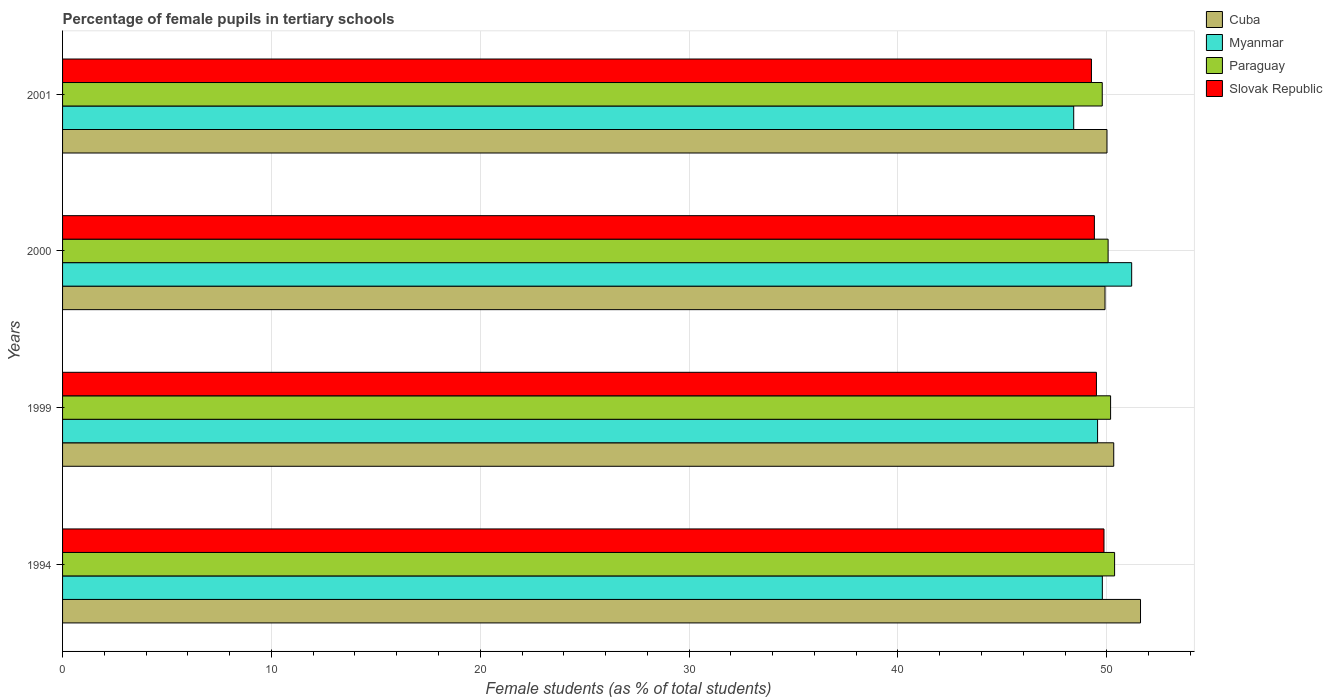Are the number of bars on each tick of the Y-axis equal?
Offer a terse response. Yes. How many bars are there on the 2nd tick from the top?
Give a very brief answer. 4. How many bars are there on the 2nd tick from the bottom?
Provide a short and direct response. 4. What is the percentage of female pupils in tertiary schools in Myanmar in 1994?
Give a very brief answer. 49.79. Across all years, what is the maximum percentage of female pupils in tertiary schools in Cuba?
Your answer should be very brief. 51.62. Across all years, what is the minimum percentage of female pupils in tertiary schools in Myanmar?
Offer a terse response. 48.42. In which year was the percentage of female pupils in tertiary schools in Cuba maximum?
Your answer should be very brief. 1994. In which year was the percentage of female pupils in tertiary schools in Paraguay minimum?
Your response must be concise. 2001. What is the total percentage of female pupils in tertiary schools in Cuba in the graph?
Keep it short and to the point. 201.88. What is the difference between the percentage of female pupils in tertiary schools in Paraguay in 1999 and that in 2001?
Make the answer very short. 0.4. What is the difference between the percentage of female pupils in tertiary schools in Paraguay in 2000 and the percentage of female pupils in tertiary schools in Slovak Republic in 2001?
Provide a succinct answer. 0.8. What is the average percentage of female pupils in tertiary schools in Cuba per year?
Provide a short and direct response. 50.47. In the year 2001, what is the difference between the percentage of female pupils in tertiary schools in Cuba and percentage of female pupils in tertiary schools in Paraguay?
Provide a short and direct response. 0.23. In how many years, is the percentage of female pupils in tertiary schools in Slovak Republic greater than 38 %?
Your answer should be compact. 4. What is the ratio of the percentage of female pupils in tertiary schools in Paraguay in 1994 to that in 1999?
Offer a terse response. 1. Is the difference between the percentage of female pupils in tertiary schools in Cuba in 1994 and 2001 greater than the difference between the percentage of female pupils in tertiary schools in Paraguay in 1994 and 2001?
Offer a very short reply. Yes. What is the difference between the highest and the second highest percentage of female pupils in tertiary schools in Myanmar?
Keep it short and to the point. 1.4. What is the difference between the highest and the lowest percentage of female pupils in tertiary schools in Paraguay?
Provide a succinct answer. 0.59. In how many years, is the percentage of female pupils in tertiary schools in Paraguay greater than the average percentage of female pupils in tertiary schools in Paraguay taken over all years?
Keep it short and to the point. 2. Is it the case that in every year, the sum of the percentage of female pupils in tertiary schools in Myanmar and percentage of female pupils in tertiary schools in Slovak Republic is greater than the sum of percentage of female pupils in tertiary schools in Paraguay and percentage of female pupils in tertiary schools in Cuba?
Give a very brief answer. No. What does the 3rd bar from the top in 1994 represents?
Make the answer very short. Myanmar. What does the 2nd bar from the bottom in 1999 represents?
Ensure brevity in your answer.  Myanmar. How many bars are there?
Provide a short and direct response. 16. Does the graph contain any zero values?
Make the answer very short. No. What is the title of the graph?
Keep it short and to the point. Percentage of female pupils in tertiary schools. What is the label or title of the X-axis?
Ensure brevity in your answer.  Female students (as % of total students). What is the label or title of the Y-axis?
Your answer should be compact. Years. What is the Female students (as % of total students) in Cuba in 1994?
Offer a terse response. 51.62. What is the Female students (as % of total students) of Myanmar in 1994?
Provide a succinct answer. 49.79. What is the Female students (as % of total students) in Paraguay in 1994?
Your answer should be very brief. 50.37. What is the Female students (as % of total students) of Slovak Republic in 1994?
Ensure brevity in your answer.  49.87. What is the Female students (as % of total students) of Cuba in 1999?
Provide a succinct answer. 50.33. What is the Female students (as % of total students) in Myanmar in 1999?
Your answer should be very brief. 49.56. What is the Female students (as % of total students) in Paraguay in 1999?
Your answer should be very brief. 50.18. What is the Female students (as % of total students) of Slovak Republic in 1999?
Make the answer very short. 49.51. What is the Female students (as % of total students) in Cuba in 2000?
Your answer should be compact. 49.92. What is the Female students (as % of total students) in Myanmar in 2000?
Keep it short and to the point. 51.19. What is the Female students (as % of total students) in Paraguay in 2000?
Offer a very short reply. 50.06. What is the Female students (as % of total students) of Slovak Republic in 2000?
Offer a terse response. 49.41. What is the Female students (as % of total students) in Cuba in 2001?
Keep it short and to the point. 50.01. What is the Female students (as % of total students) of Myanmar in 2001?
Your response must be concise. 48.42. What is the Female students (as % of total students) of Paraguay in 2001?
Your answer should be very brief. 49.78. What is the Female students (as % of total students) of Slovak Republic in 2001?
Offer a very short reply. 49.27. Across all years, what is the maximum Female students (as % of total students) in Cuba?
Offer a terse response. 51.62. Across all years, what is the maximum Female students (as % of total students) of Myanmar?
Ensure brevity in your answer.  51.19. Across all years, what is the maximum Female students (as % of total students) in Paraguay?
Make the answer very short. 50.37. Across all years, what is the maximum Female students (as % of total students) in Slovak Republic?
Provide a short and direct response. 49.87. Across all years, what is the minimum Female students (as % of total students) in Cuba?
Your answer should be very brief. 49.92. Across all years, what is the minimum Female students (as % of total students) of Myanmar?
Your answer should be compact. 48.42. Across all years, what is the minimum Female students (as % of total students) in Paraguay?
Provide a short and direct response. 49.78. Across all years, what is the minimum Female students (as % of total students) in Slovak Republic?
Your answer should be compact. 49.27. What is the total Female students (as % of total students) of Cuba in the graph?
Ensure brevity in your answer.  201.88. What is the total Female students (as % of total students) of Myanmar in the graph?
Offer a very short reply. 198.96. What is the total Female students (as % of total students) in Paraguay in the graph?
Provide a succinct answer. 200.41. What is the total Female students (as % of total students) of Slovak Republic in the graph?
Provide a short and direct response. 198.05. What is the difference between the Female students (as % of total students) of Cuba in 1994 and that in 1999?
Provide a succinct answer. 1.28. What is the difference between the Female students (as % of total students) of Myanmar in 1994 and that in 1999?
Your answer should be compact. 0.23. What is the difference between the Female students (as % of total students) in Paraguay in 1994 and that in 1999?
Provide a short and direct response. 0.19. What is the difference between the Female students (as % of total students) of Slovak Republic in 1994 and that in 1999?
Your answer should be very brief. 0.36. What is the difference between the Female students (as % of total students) of Myanmar in 1994 and that in 2000?
Your answer should be compact. -1.4. What is the difference between the Female students (as % of total students) in Paraguay in 1994 and that in 2000?
Provide a short and direct response. 0.31. What is the difference between the Female students (as % of total students) in Slovak Republic in 1994 and that in 2000?
Provide a short and direct response. 0.46. What is the difference between the Female students (as % of total students) of Cuba in 1994 and that in 2001?
Ensure brevity in your answer.  1.61. What is the difference between the Female students (as % of total students) in Myanmar in 1994 and that in 2001?
Your answer should be compact. 1.37. What is the difference between the Female students (as % of total students) in Paraguay in 1994 and that in 2001?
Provide a short and direct response. 0.59. What is the difference between the Female students (as % of total students) of Slovak Republic in 1994 and that in 2001?
Give a very brief answer. 0.6. What is the difference between the Female students (as % of total students) of Cuba in 1999 and that in 2000?
Offer a very short reply. 0.42. What is the difference between the Female students (as % of total students) of Myanmar in 1999 and that in 2000?
Offer a very short reply. -1.63. What is the difference between the Female students (as % of total students) of Paraguay in 1999 and that in 2000?
Ensure brevity in your answer.  0.12. What is the difference between the Female students (as % of total students) in Slovak Republic in 1999 and that in 2000?
Provide a succinct answer. 0.1. What is the difference between the Female students (as % of total students) of Cuba in 1999 and that in 2001?
Keep it short and to the point. 0.32. What is the difference between the Female students (as % of total students) of Myanmar in 1999 and that in 2001?
Provide a succinct answer. 1.14. What is the difference between the Female students (as % of total students) in Paraguay in 1999 and that in 2001?
Provide a succinct answer. 0.4. What is the difference between the Female students (as % of total students) in Slovak Republic in 1999 and that in 2001?
Ensure brevity in your answer.  0.24. What is the difference between the Female students (as % of total students) of Cuba in 2000 and that in 2001?
Keep it short and to the point. -0.09. What is the difference between the Female students (as % of total students) of Myanmar in 2000 and that in 2001?
Keep it short and to the point. 2.78. What is the difference between the Female students (as % of total students) of Paraguay in 2000 and that in 2001?
Your response must be concise. 0.28. What is the difference between the Female students (as % of total students) of Slovak Republic in 2000 and that in 2001?
Provide a short and direct response. 0.14. What is the difference between the Female students (as % of total students) of Cuba in 1994 and the Female students (as % of total students) of Myanmar in 1999?
Offer a terse response. 2.06. What is the difference between the Female students (as % of total students) of Cuba in 1994 and the Female students (as % of total students) of Paraguay in 1999?
Provide a succinct answer. 1.43. What is the difference between the Female students (as % of total students) in Cuba in 1994 and the Female students (as % of total students) in Slovak Republic in 1999?
Ensure brevity in your answer.  2.11. What is the difference between the Female students (as % of total students) of Myanmar in 1994 and the Female students (as % of total students) of Paraguay in 1999?
Offer a terse response. -0.4. What is the difference between the Female students (as % of total students) of Myanmar in 1994 and the Female students (as % of total students) of Slovak Republic in 1999?
Your response must be concise. 0.28. What is the difference between the Female students (as % of total students) of Paraguay in 1994 and the Female students (as % of total students) of Slovak Republic in 1999?
Your answer should be very brief. 0.87. What is the difference between the Female students (as % of total students) in Cuba in 1994 and the Female students (as % of total students) in Myanmar in 2000?
Ensure brevity in your answer.  0.42. What is the difference between the Female students (as % of total students) of Cuba in 1994 and the Female students (as % of total students) of Paraguay in 2000?
Keep it short and to the point. 1.55. What is the difference between the Female students (as % of total students) in Cuba in 1994 and the Female students (as % of total students) in Slovak Republic in 2000?
Give a very brief answer. 2.21. What is the difference between the Female students (as % of total students) of Myanmar in 1994 and the Female students (as % of total students) of Paraguay in 2000?
Provide a succinct answer. -0.28. What is the difference between the Female students (as % of total students) in Myanmar in 1994 and the Female students (as % of total students) in Slovak Republic in 2000?
Make the answer very short. 0.38. What is the difference between the Female students (as % of total students) of Paraguay in 1994 and the Female students (as % of total students) of Slovak Republic in 2000?
Provide a succinct answer. 0.97. What is the difference between the Female students (as % of total students) in Cuba in 1994 and the Female students (as % of total students) in Myanmar in 2001?
Your answer should be very brief. 3.2. What is the difference between the Female students (as % of total students) of Cuba in 1994 and the Female students (as % of total students) of Paraguay in 2001?
Your answer should be very brief. 1.83. What is the difference between the Female students (as % of total students) in Cuba in 1994 and the Female students (as % of total students) in Slovak Republic in 2001?
Offer a terse response. 2.35. What is the difference between the Female students (as % of total students) in Myanmar in 1994 and the Female students (as % of total students) in Paraguay in 2001?
Your response must be concise. 0. What is the difference between the Female students (as % of total students) of Myanmar in 1994 and the Female students (as % of total students) of Slovak Republic in 2001?
Your answer should be very brief. 0.52. What is the difference between the Female students (as % of total students) in Paraguay in 1994 and the Female students (as % of total students) in Slovak Republic in 2001?
Your answer should be compact. 1.11. What is the difference between the Female students (as % of total students) in Cuba in 1999 and the Female students (as % of total students) in Myanmar in 2000?
Provide a short and direct response. -0.86. What is the difference between the Female students (as % of total students) of Cuba in 1999 and the Female students (as % of total students) of Paraguay in 2000?
Offer a very short reply. 0.27. What is the difference between the Female students (as % of total students) of Cuba in 1999 and the Female students (as % of total students) of Slovak Republic in 2000?
Your answer should be very brief. 0.93. What is the difference between the Female students (as % of total students) in Myanmar in 1999 and the Female students (as % of total students) in Paraguay in 2000?
Your answer should be very brief. -0.5. What is the difference between the Female students (as % of total students) of Myanmar in 1999 and the Female students (as % of total students) of Slovak Republic in 2000?
Provide a short and direct response. 0.15. What is the difference between the Female students (as % of total students) in Paraguay in 1999 and the Female students (as % of total students) in Slovak Republic in 2000?
Ensure brevity in your answer.  0.78. What is the difference between the Female students (as % of total students) in Cuba in 1999 and the Female students (as % of total students) in Myanmar in 2001?
Keep it short and to the point. 1.92. What is the difference between the Female students (as % of total students) in Cuba in 1999 and the Female students (as % of total students) in Paraguay in 2001?
Provide a succinct answer. 0.55. What is the difference between the Female students (as % of total students) in Cuba in 1999 and the Female students (as % of total students) in Slovak Republic in 2001?
Your answer should be very brief. 1.07. What is the difference between the Female students (as % of total students) in Myanmar in 1999 and the Female students (as % of total students) in Paraguay in 2001?
Keep it short and to the point. -0.22. What is the difference between the Female students (as % of total students) of Myanmar in 1999 and the Female students (as % of total students) of Slovak Republic in 2001?
Make the answer very short. 0.29. What is the difference between the Female students (as % of total students) of Paraguay in 1999 and the Female students (as % of total students) of Slovak Republic in 2001?
Your response must be concise. 0.92. What is the difference between the Female students (as % of total students) of Cuba in 2000 and the Female students (as % of total students) of Myanmar in 2001?
Your answer should be very brief. 1.5. What is the difference between the Female students (as % of total students) in Cuba in 2000 and the Female students (as % of total students) in Paraguay in 2001?
Make the answer very short. 0.13. What is the difference between the Female students (as % of total students) in Cuba in 2000 and the Female students (as % of total students) in Slovak Republic in 2001?
Your response must be concise. 0.65. What is the difference between the Female students (as % of total students) in Myanmar in 2000 and the Female students (as % of total students) in Paraguay in 2001?
Keep it short and to the point. 1.41. What is the difference between the Female students (as % of total students) in Myanmar in 2000 and the Female students (as % of total students) in Slovak Republic in 2001?
Offer a terse response. 1.93. What is the difference between the Female students (as % of total students) in Paraguay in 2000 and the Female students (as % of total students) in Slovak Republic in 2001?
Give a very brief answer. 0.8. What is the average Female students (as % of total students) in Cuba per year?
Give a very brief answer. 50.47. What is the average Female students (as % of total students) in Myanmar per year?
Your response must be concise. 49.74. What is the average Female students (as % of total students) of Paraguay per year?
Offer a very short reply. 50.1. What is the average Female students (as % of total students) in Slovak Republic per year?
Your answer should be compact. 49.51. In the year 1994, what is the difference between the Female students (as % of total students) of Cuba and Female students (as % of total students) of Myanmar?
Your answer should be compact. 1.83. In the year 1994, what is the difference between the Female students (as % of total students) in Cuba and Female students (as % of total students) in Paraguay?
Offer a very short reply. 1.24. In the year 1994, what is the difference between the Female students (as % of total students) of Cuba and Female students (as % of total students) of Slovak Republic?
Provide a succinct answer. 1.75. In the year 1994, what is the difference between the Female students (as % of total students) of Myanmar and Female students (as % of total students) of Paraguay?
Ensure brevity in your answer.  -0.59. In the year 1994, what is the difference between the Female students (as % of total students) of Myanmar and Female students (as % of total students) of Slovak Republic?
Provide a succinct answer. -0.08. In the year 1994, what is the difference between the Female students (as % of total students) in Paraguay and Female students (as % of total students) in Slovak Republic?
Ensure brevity in your answer.  0.51. In the year 1999, what is the difference between the Female students (as % of total students) in Cuba and Female students (as % of total students) in Myanmar?
Ensure brevity in your answer.  0.77. In the year 1999, what is the difference between the Female students (as % of total students) in Cuba and Female students (as % of total students) in Paraguay?
Keep it short and to the point. 0.15. In the year 1999, what is the difference between the Female students (as % of total students) in Cuba and Female students (as % of total students) in Slovak Republic?
Your answer should be very brief. 0.83. In the year 1999, what is the difference between the Female students (as % of total students) of Myanmar and Female students (as % of total students) of Paraguay?
Your response must be concise. -0.62. In the year 1999, what is the difference between the Female students (as % of total students) in Myanmar and Female students (as % of total students) in Slovak Republic?
Keep it short and to the point. 0.05. In the year 1999, what is the difference between the Female students (as % of total students) of Paraguay and Female students (as % of total students) of Slovak Republic?
Give a very brief answer. 0.68. In the year 2000, what is the difference between the Female students (as % of total students) in Cuba and Female students (as % of total students) in Myanmar?
Your answer should be compact. -1.28. In the year 2000, what is the difference between the Female students (as % of total students) in Cuba and Female students (as % of total students) in Paraguay?
Provide a succinct answer. -0.15. In the year 2000, what is the difference between the Female students (as % of total students) in Cuba and Female students (as % of total students) in Slovak Republic?
Your response must be concise. 0.51. In the year 2000, what is the difference between the Female students (as % of total students) of Myanmar and Female students (as % of total students) of Paraguay?
Provide a succinct answer. 1.13. In the year 2000, what is the difference between the Female students (as % of total students) in Myanmar and Female students (as % of total students) in Slovak Republic?
Offer a terse response. 1.79. In the year 2000, what is the difference between the Female students (as % of total students) of Paraguay and Female students (as % of total students) of Slovak Republic?
Your answer should be compact. 0.66. In the year 2001, what is the difference between the Female students (as % of total students) of Cuba and Female students (as % of total students) of Myanmar?
Provide a short and direct response. 1.59. In the year 2001, what is the difference between the Female students (as % of total students) in Cuba and Female students (as % of total students) in Paraguay?
Your answer should be compact. 0.23. In the year 2001, what is the difference between the Female students (as % of total students) of Cuba and Female students (as % of total students) of Slovak Republic?
Your answer should be very brief. 0.74. In the year 2001, what is the difference between the Female students (as % of total students) in Myanmar and Female students (as % of total students) in Paraguay?
Ensure brevity in your answer.  -1.37. In the year 2001, what is the difference between the Female students (as % of total students) of Myanmar and Female students (as % of total students) of Slovak Republic?
Keep it short and to the point. -0.85. In the year 2001, what is the difference between the Female students (as % of total students) of Paraguay and Female students (as % of total students) of Slovak Republic?
Provide a succinct answer. 0.52. What is the ratio of the Female students (as % of total students) in Cuba in 1994 to that in 1999?
Keep it short and to the point. 1.03. What is the ratio of the Female students (as % of total students) of Myanmar in 1994 to that in 1999?
Make the answer very short. 1. What is the ratio of the Female students (as % of total students) of Paraguay in 1994 to that in 1999?
Your answer should be compact. 1. What is the ratio of the Female students (as % of total students) in Slovak Republic in 1994 to that in 1999?
Provide a succinct answer. 1.01. What is the ratio of the Female students (as % of total students) in Cuba in 1994 to that in 2000?
Offer a terse response. 1.03. What is the ratio of the Female students (as % of total students) of Myanmar in 1994 to that in 2000?
Keep it short and to the point. 0.97. What is the ratio of the Female students (as % of total students) in Paraguay in 1994 to that in 2000?
Keep it short and to the point. 1.01. What is the ratio of the Female students (as % of total students) of Slovak Republic in 1994 to that in 2000?
Make the answer very short. 1.01. What is the ratio of the Female students (as % of total students) in Cuba in 1994 to that in 2001?
Keep it short and to the point. 1.03. What is the ratio of the Female students (as % of total students) of Myanmar in 1994 to that in 2001?
Make the answer very short. 1.03. What is the ratio of the Female students (as % of total students) in Paraguay in 1994 to that in 2001?
Provide a short and direct response. 1.01. What is the ratio of the Female students (as % of total students) of Slovak Republic in 1994 to that in 2001?
Provide a short and direct response. 1.01. What is the ratio of the Female students (as % of total students) in Cuba in 1999 to that in 2000?
Ensure brevity in your answer.  1.01. What is the ratio of the Female students (as % of total students) in Myanmar in 1999 to that in 2000?
Give a very brief answer. 0.97. What is the ratio of the Female students (as % of total students) of Paraguay in 1999 to that in 2000?
Provide a succinct answer. 1. What is the ratio of the Female students (as % of total students) in Cuba in 1999 to that in 2001?
Provide a short and direct response. 1.01. What is the ratio of the Female students (as % of total students) in Myanmar in 1999 to that in 2001?
Keep it short and to the point. 1.02. What is the ratio of the Female students (as % of total students) in Slovak Republic in 1999 to that in 2001?
Provide a short and direct response. 1. What is the ratio of the Female students (as % of total students) of Cuba in 2000 to that in 2001?
Your response must be concise. 1. What is the ratio of the Female students (as % of total students) in Myanmar in 2000 to that in 2001?
Give a very brief answer. 1.06. What is the ratio of the Female students (as % of total students) in Paraguay in 2000 to that in 2001?
Your response must be concise. 1.01. What is the difference between the highest and the second highest Female students (as % of total students) in Cuba?
Your answer should be compact. 1.28. What is the difference between the highest and the second highest Female students (as % of total students) of Myanmar?
Your response must be concise. 1.4. What is the difference between the highest and the second highest Female students (as % of total students) of Paraguay?
Give a very brief answer. 0.19. What is the difference between the highest and the second highest Female students (as % of total students) of Slovak Republic?
Provide a short and direct response. 0.36. What is the difference between the highest and the lowest Female students (as % of total students) of Myanmar?
Your answer should be very brief. 2.78. What is the difference between the highest and the lowest Female students (as % of total students) in Paraguay?
Offer a terse response. 0.59. What is the difference between the highest and the lowest Female students (as % of total students) in Slovak Republic?
Provide a succinct answer. 0.6. 